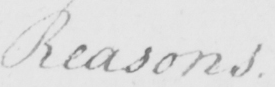Can you read and transcribe this handwriting? Reasons. 